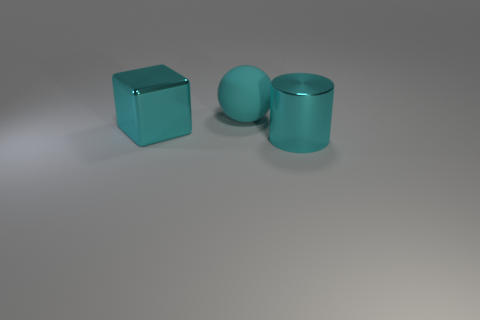There is a rubber thing; is its color the same as the metal thing behind the cylinder?
Provide a short and direct response. Yes. What number of big shiny cylinders are in front of the large cyan matte sphere?
Give a very brief answer. 1. There is a big cyan object that is left of the cyan cylinder and to the right of the large shiny cube; what is it made of?
Your response must be concise. Rubber. What number of big objects are yellow cubes or cyan objects?
Offer a very short reply. 3. What is the size of the cyan cylinder?
Give a very brief answer. Large. What is the shape of the large matte object?
Provide a succinct answer. Sphere. Is there any other thing that has the same shape as the cyan matte thing?
Your answer should be very brief. No. Are there fewer matte balls behind the large cyan matte ball than tiny blue metal things?
Provide a succinct answer. No. There is a object right of the big sphere; is it the same color as the large block?
Ensure brevity in your answer.  Yes. What number of matte objects are either small cyan balls or cyan cylinders?
Provide a short and direct response. 0. 